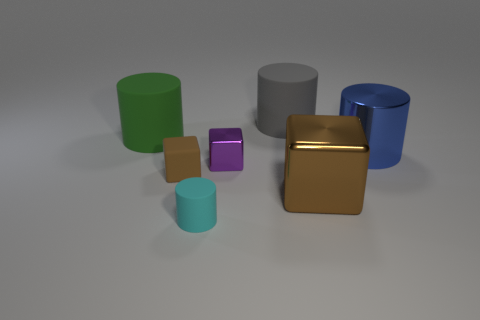What number of objects are either cyan matte cylinders or purple blocks?
Make the answer very short. 2. There is a large thing that is the same color as the rubber cube; what is it made of?
Keep it short and to the point. Metal. Is there a blue object of the same shape as the big gray rubber thing?
Your answer should be compact. Yes. There is a purple thing; what number of big rubber cylinders are behind it?
Offer a very short reply. 2. The brown thing on the left side of the tiny cube that is to the right of the brown matte object is made of what material?
Make the answer very short. Rubber. What material is the cylinder that is the same size as the brown rubber block?
Keep it short and to the point. Rubber. Is there a blue matte block that has the same size as the blue cylinder?
Make the answer very short. No. There is a metallic block that is in front of the small purple metal object; what is its color?
Provide a short and direct response. Brown. There is a large thing on the right side of the large brown shiny thing; are there any green cylinders that are behind it?
Your response must be concise. Yes. What number of other things are there of the same color as the shiny cylinder?
Provide a short and direct response. 0. 